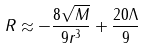<formula> <loc_0><loc_0><loc_500><loc_500>R \approx - \frac { 8 \sqrt { M } } { 9 r ^ { 3 } } + \frac { 2 0 \Lambda } { 9 }</formula> 